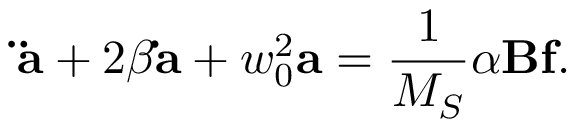Convert formula to latex. <formula><loc_0><loc_0><loc_500><loc_500>{ \ddot { a } } + 2 \beta { \dot { a } } + w _ { 0 } ^ { 2 } { a } = \frac { 1 } { M _ { S } } \alpha { B } { f } .</formula> 